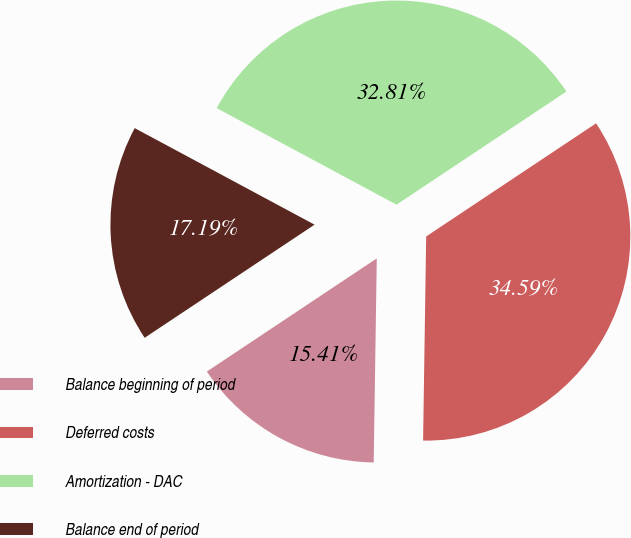<chart> <loc_0><loc_0><loc_500><loc_500><pie_chart><fcel>Balance beginning of period<fcel>Deferred costs<fcel>Amortization - DAC<fcel>Balance end of period<nl><fcel>15.41%<fcel>34.59%<fcel>32.81%<fcel>17.19%<nl></chart> 